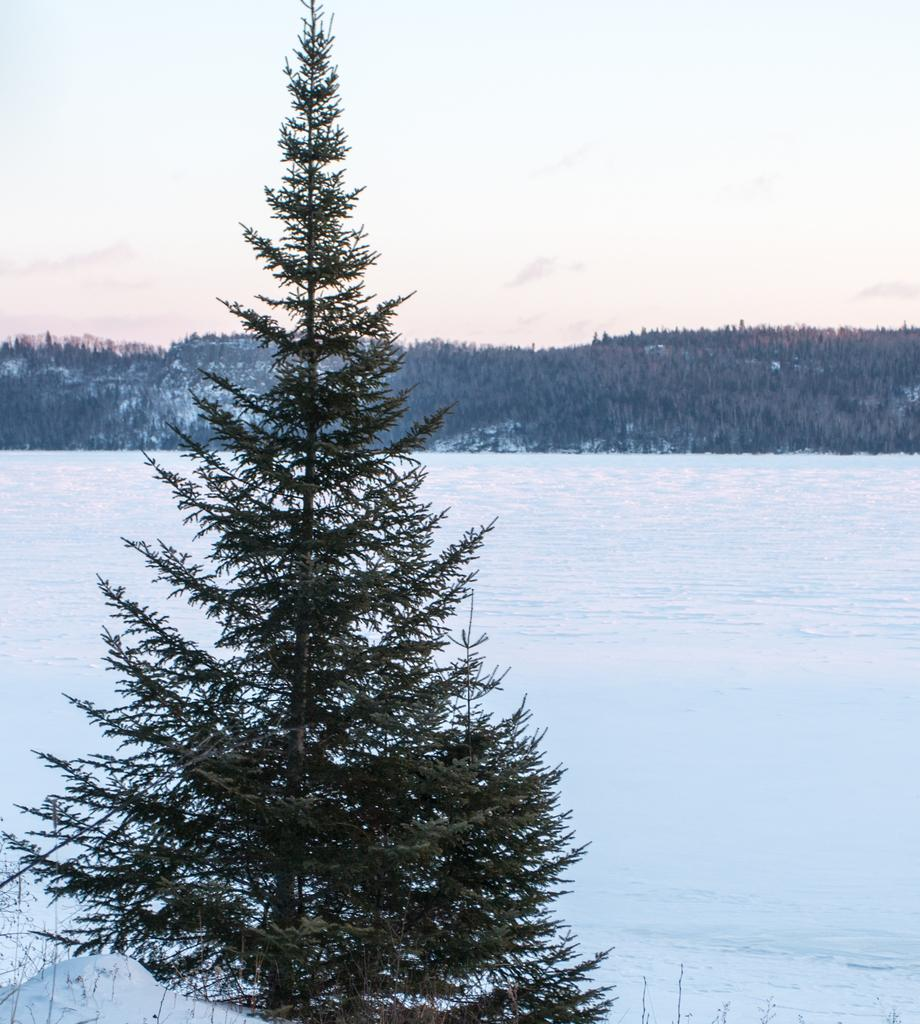What is located on the snow in the image? There is a tree on the snow in the image. What can be seen in the background of the image? Water, trees, and clouds are visible in the background of the image. How many bikes are parked near the tree on the snow? There are no bikes present in the image. What type of knee injury can be seen on the tree in the image? There is no knee injury present on the tree in the image, as it is a tree and not a person. 